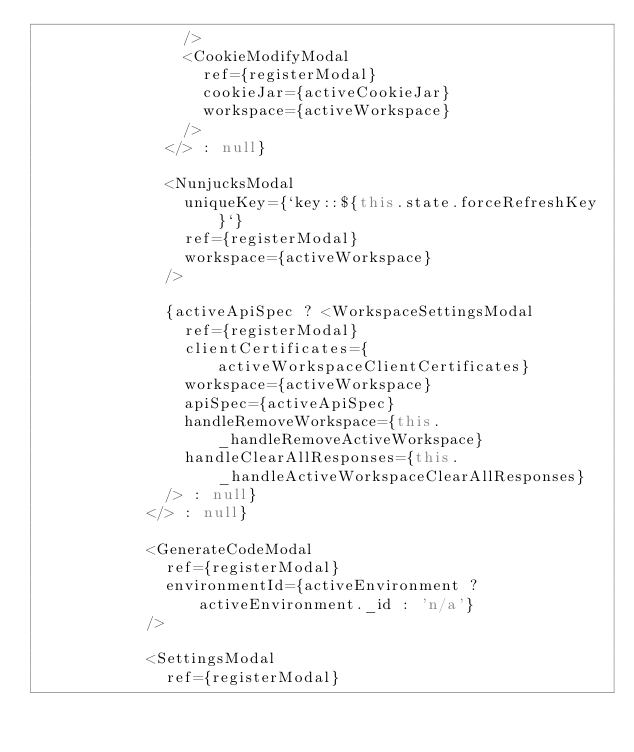Convert code to text. <code><loc_0><loc_0><loc_500><loc_500><_TypeScript_>                />
                <CookieModifyModal
                  ref={registerModal}
                  cookieJar={activeCookieJar}
                  workspace={activeWorkspace}
                />
              </> : null}

              <NunjucksModal
                uniqueKey={`key::${this.state.forceRefreshKey}`}
                ref={registerModal}
                workspace={activeWorkspace}
              />

              {activeApiSpec ? <WorkspaceSettingsModal
                ref={registerModal}
                clientCertificates={activeWorkspaceClientCertificates}
                workspace={activeWorkspace}
                apiSpec={activeApiSpec}
                handleRemoveWorkspace={this._handleRemoveActiveWorkspace}
                handleClearAllResponses={this._handleActiveWorkspaceClearAllResponses}
              /> : null}
            </> : null}

            <GenerateCodeModal
              ref={registerModal}
              environmentId={activeEnvironment ? activeEnvironment._id : 'n/a'}
            />

            <SettingsModal
              ref={registerModal}</code> 